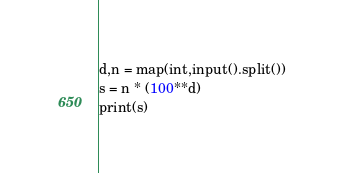<code> <loc_0><loc_0><loc_500><loc_500><_Python_>d,n = map(int,input().split())
s = n * (100**d)
print(s)</code> 